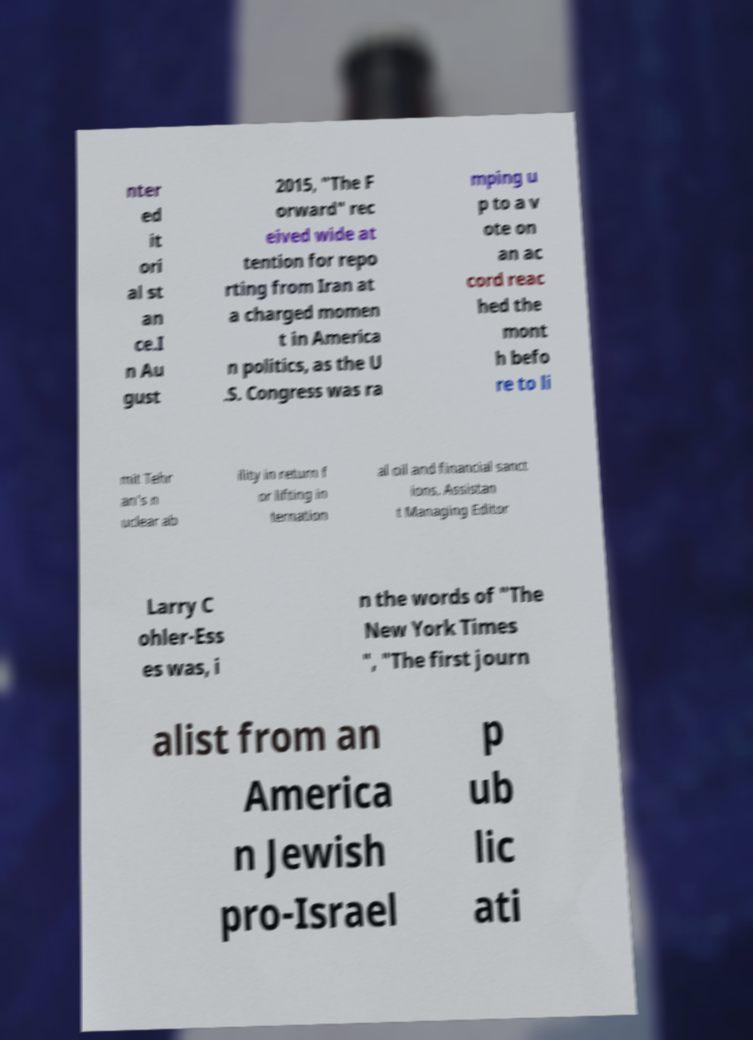I need the written content from this picture converted into text. Can you do that? nter ed it ori al st an ce.I n Au gust 2015, "The F orward" rec eived wide at tention for repo rting from Iran at a charged momen t in America n politics, as the U .S. Congress was ra mping u p to a v ote on an ac cord reac hed the mont h befo re to li mit Tehr an's n uclear ab ility in return f or lifting in ternation al oil and financial sanct ions. Assistan t Managing Editor Larry C ohler-Ess es was, i n the words of "The New York Times ", "The first journ alist from an America n Jewish pro-Israel p ub lic ati 